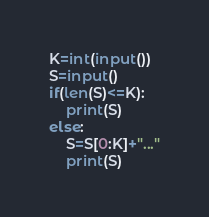Convert code to text. <code><loc_0><loc_0><loc_500><loc_500><_Python_>K=int(input())
S=input()
if(len(S)<=K):
    print(S)
else:
    S=S[0:K]+"..."
    print(S)</code> 